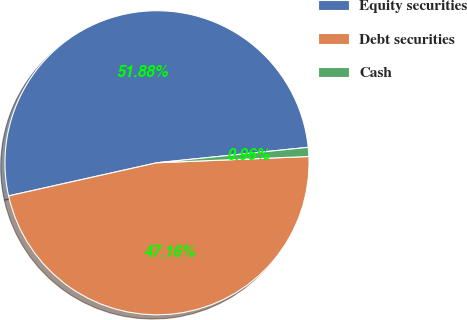Convert chart to OTSL. <chart><loc_0><loc_0><loc_500><loc_500><pie_chart><fcel>Equity securities<fcel>Debt securities<fcel>Cash<nl><fcel>51.88%<fcel>47.16%<fcel>0.96%<nl></chart> 